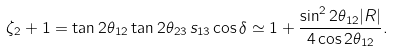<formula> <loc_0><loc_0><loc_500><loc_500>\zeta _ { 2 } + 1 = \tan { 2 \theta _ { 1 2 } } \tan { 2 \theta _ { 2 3 } } \, s _ { 1 3 } \cos { \delta } \simeq 1 + \frac { \sin ^ { 2 } { 2 \theta _ { 1 2 } } | R | } { 4 \cos { 2 \theta _ { 1 2 } } } .</formula> 